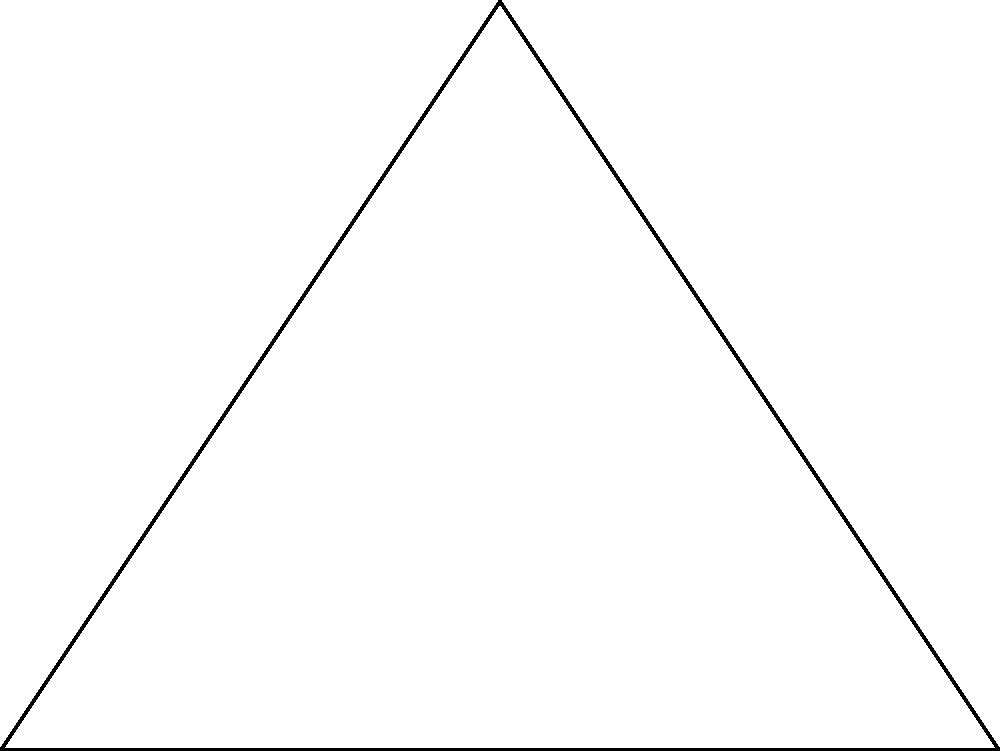A travel gear company is designing a new triangular travel pillow. The pillow's base is 8 cm wide, and its height is 6 cm. To optimize comfort and packability, the company wants to determine the length of the line from the midpoint of one side to the opposite vertex. What is the length of this line, rounded to the nearest 0.1 cm? Let's approach this step-by-step:

1) The triangle has a base of 8 cm and a height of 6 cm. This forms a right-angled triangle.

2) We need to find the length of the line from the midpoint of AC to point B. Let's call this length x.

3) The midpoint of AC divides the height of the triangle in half. So, the height from this midpoint to AB is 3 cm.

4) We now have a right-angled triangle with:
   - Base = 4 cm (half of AB)
   - Height = 3 cm

5) We can use the Pythagorean theorem to find x:

   $$x^2 = 4^2 + 3^2$$

6) Simplify:
   $$x^2 = 16 + 9 = 25$$

7) Take the square root of both sides:
   $$x = \sqrt{25} = 5$$

8) Therefore, the length of the line is 5 cm.

Rounding to the nearest 0.1 cm is not necessary in this case as 5 cm is already a whole number.
Answer: 5 cm 